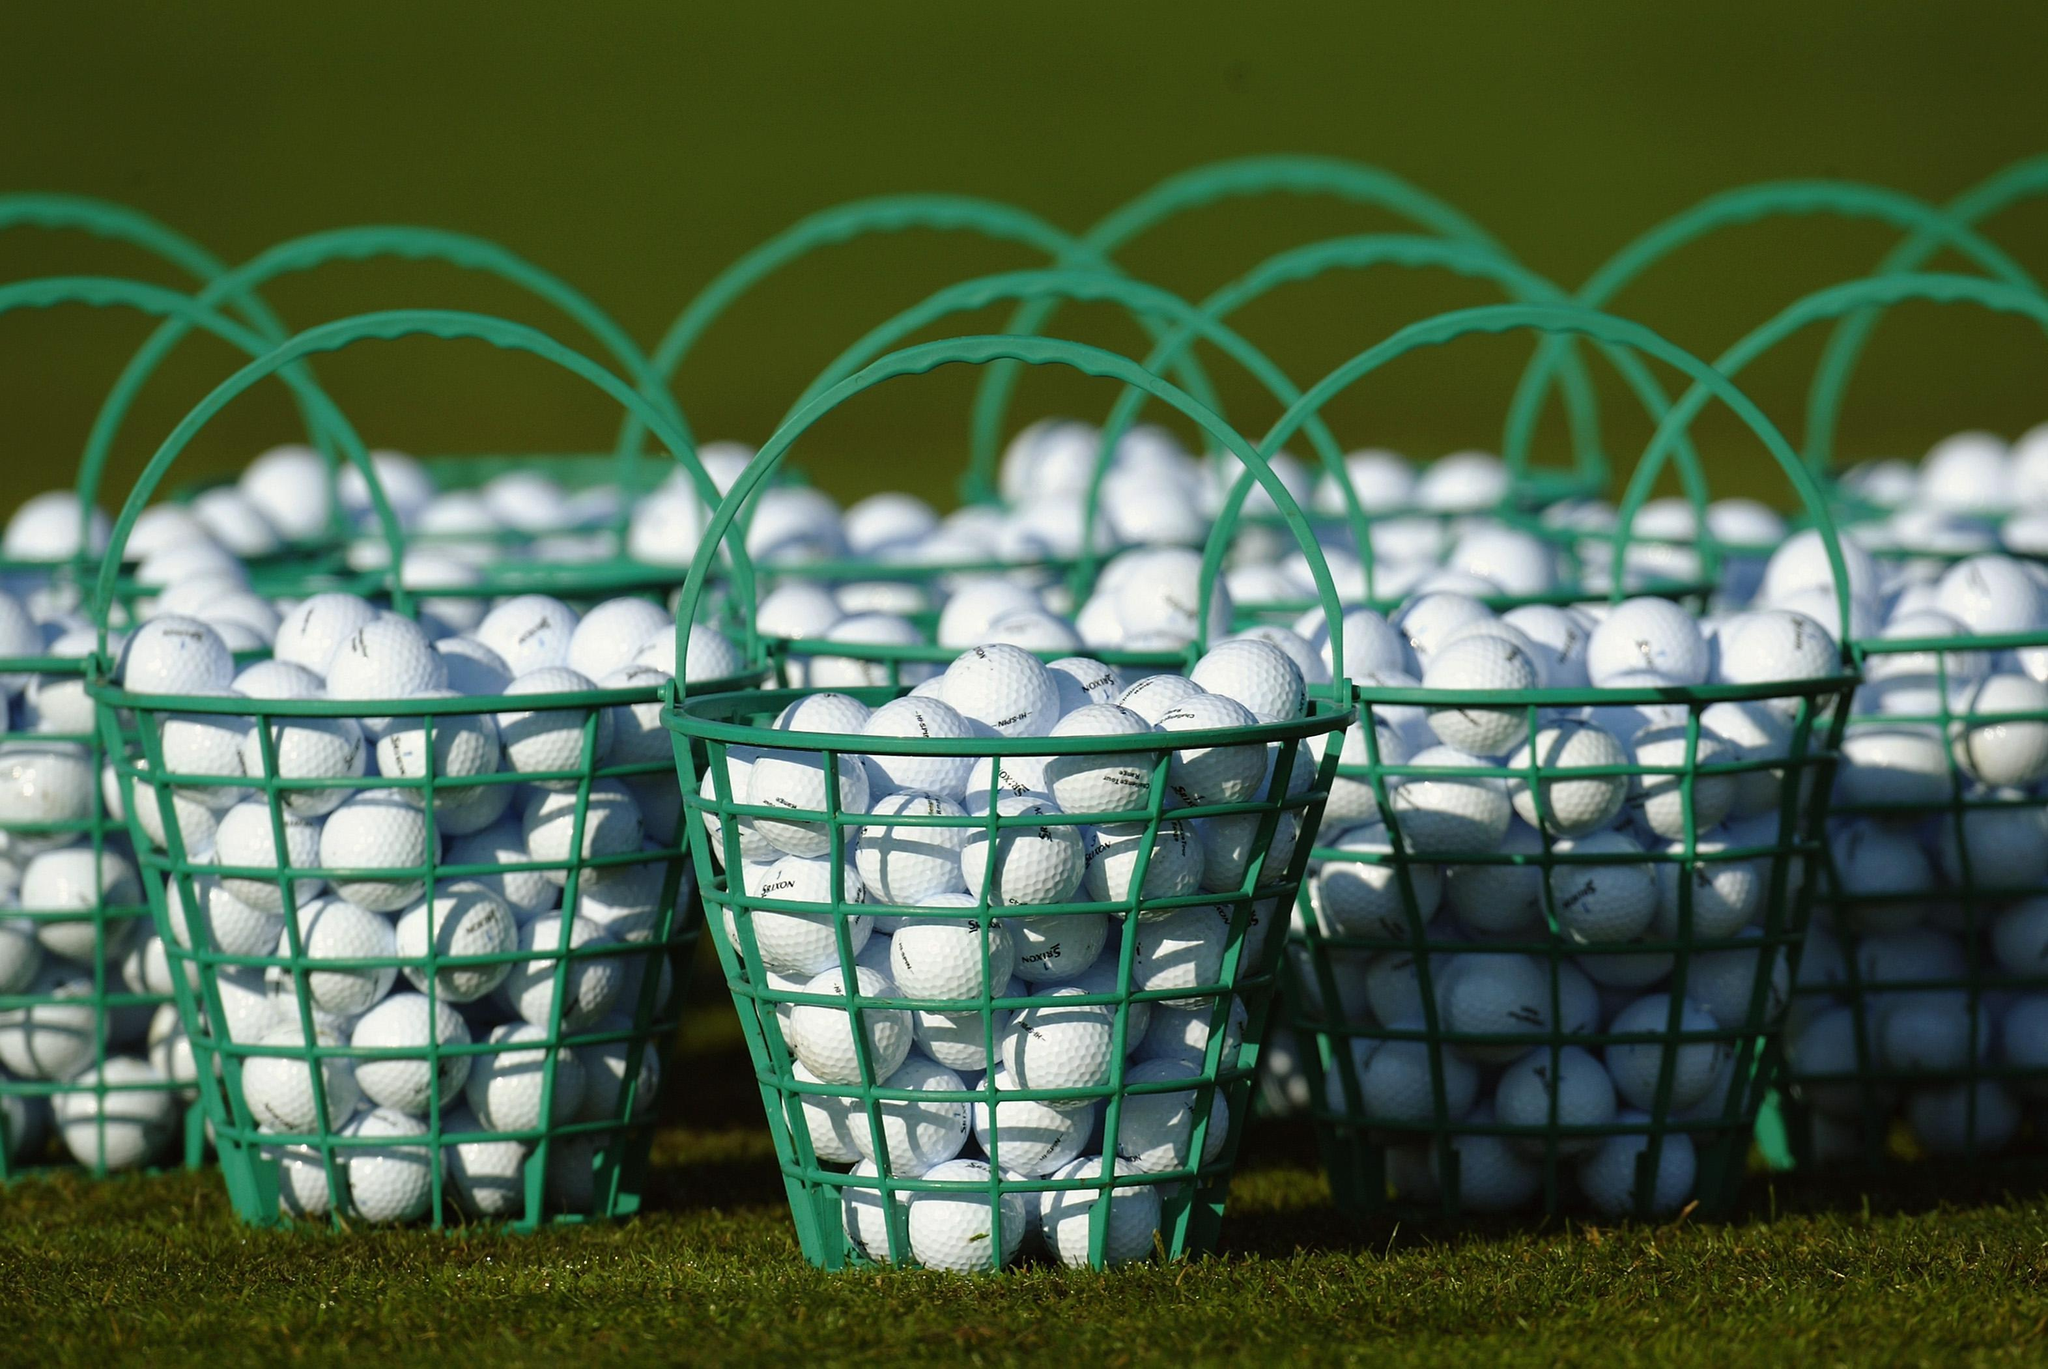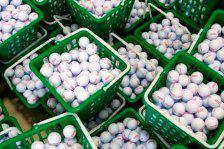The first image is the image on the left, the second image is the image on the right. Given the left and right images, does the statement "A golf club is next to at least one golf ball in one image." hold true? Answer yes or no. No. The first image is the image on the left, the second image is the image on the right. Evaluate the accuracy of this statement regarding the images: "In one photo, a green bucket of golf balls is laying on its side in grass with no golf clubs visible". Is it true? Answer yes or no. No. 